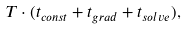<formula> <loc_0><loc_0><loc_500><loc_500>T \cdot ( t _ { c o n s t } + t _ { g r a d } + t _ { s o l v e } ) ,</formula> 